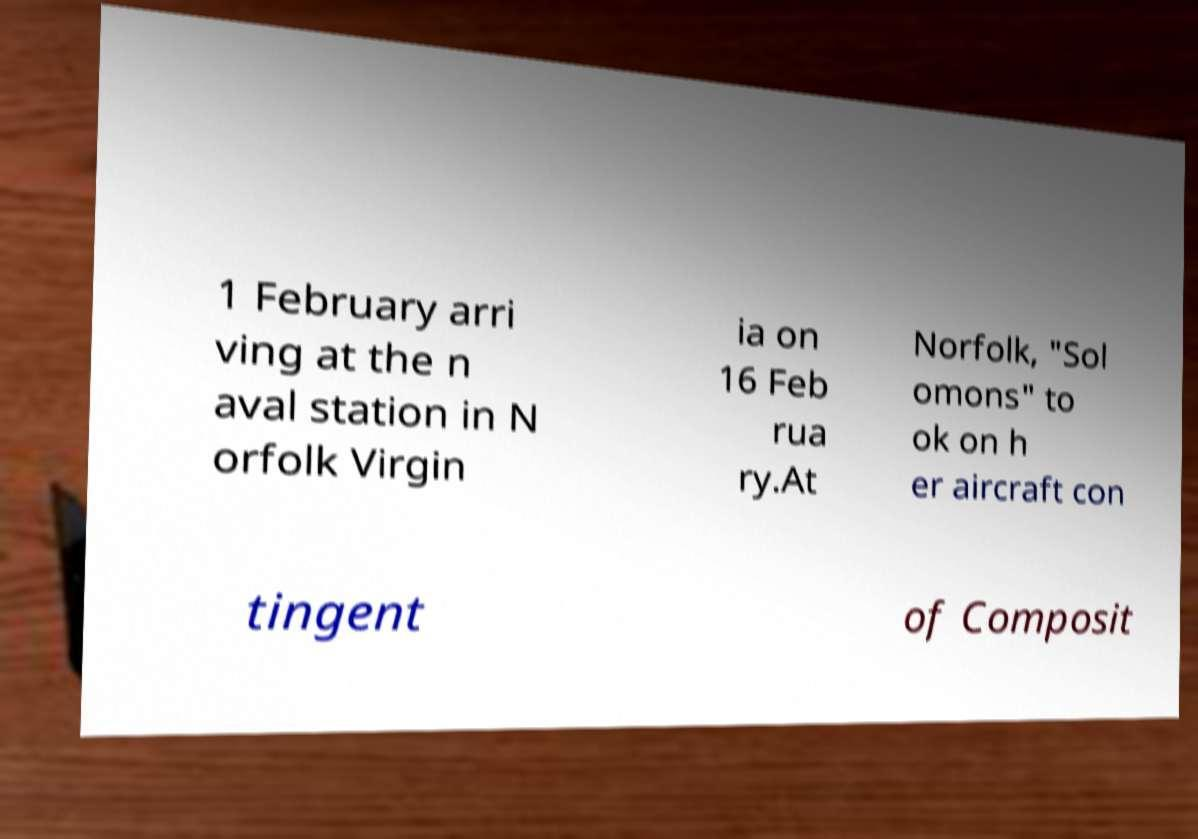I need the written content from this picture converted into text. Can you do that? 1 February arri ving at the n aval station in N orfolk Virgin ia on 16 Feb rua ry.At Norfolk, "Sol omons" to ok on h er aircraft con tingent of Composit 